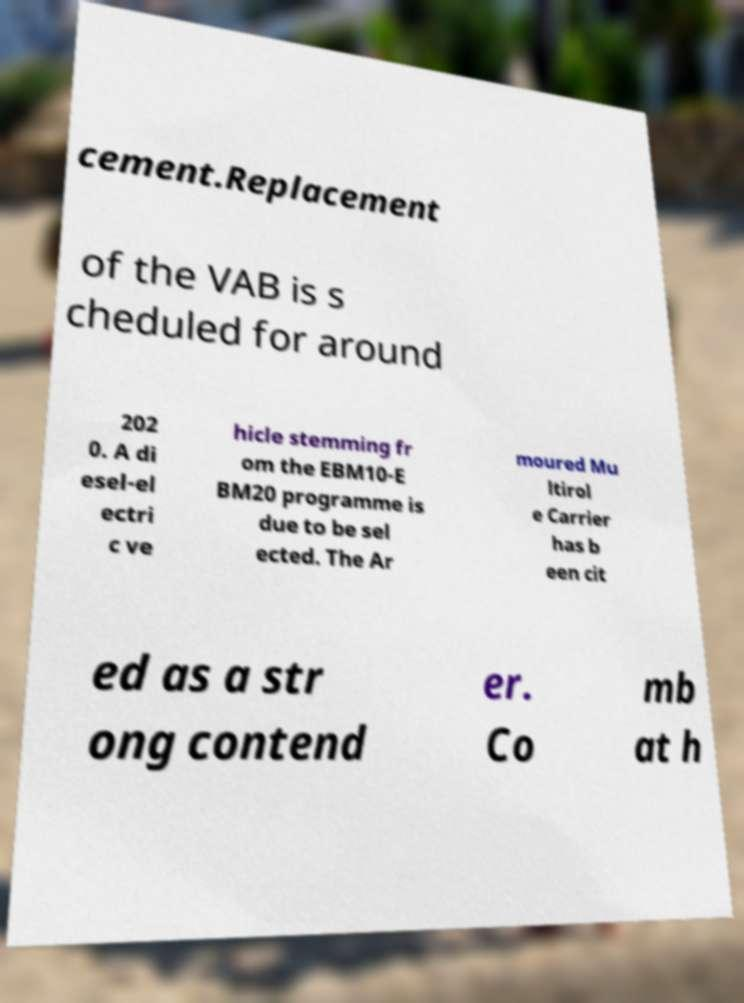What messages or text are displayed in this image? I need them in a readable, typed format. cement.Replacement of the VAB is s cheduled for around 202 0. A di esel-el ectri c ve hicle stemming fr om the EBM10-E BM20 programme is due to be sel ected. The Ar moured Mu ltirol e Carrier has b een cit ed as a str ong contend er. Co mb at h 